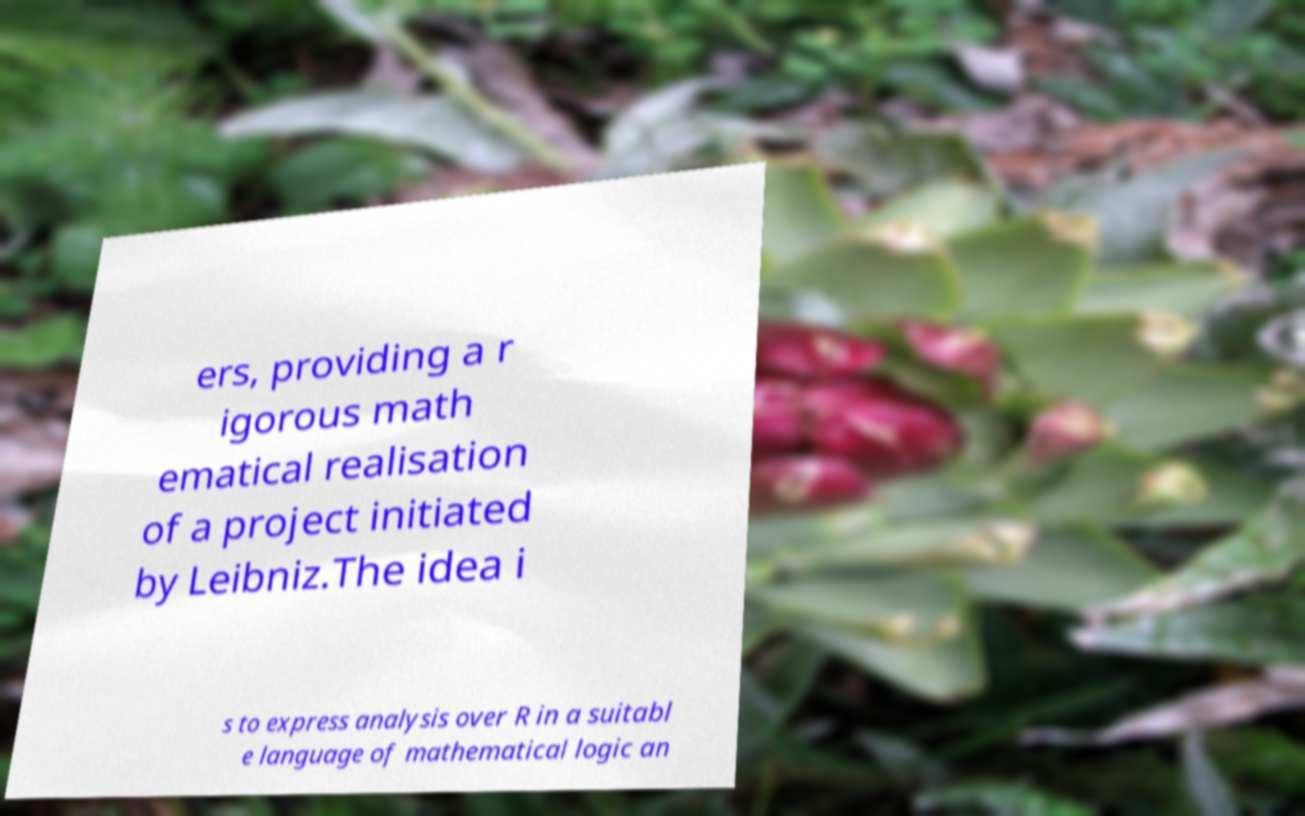Can you read and provide the text displayed in the image?This photo seems to have some interesting text. Can you extract and type it out for me? ers, providing a r igorous math ematical realisation of a project initiated by Leibniz.The idea i s to express analysis over R in a suitabl e language of mathematical logic an 